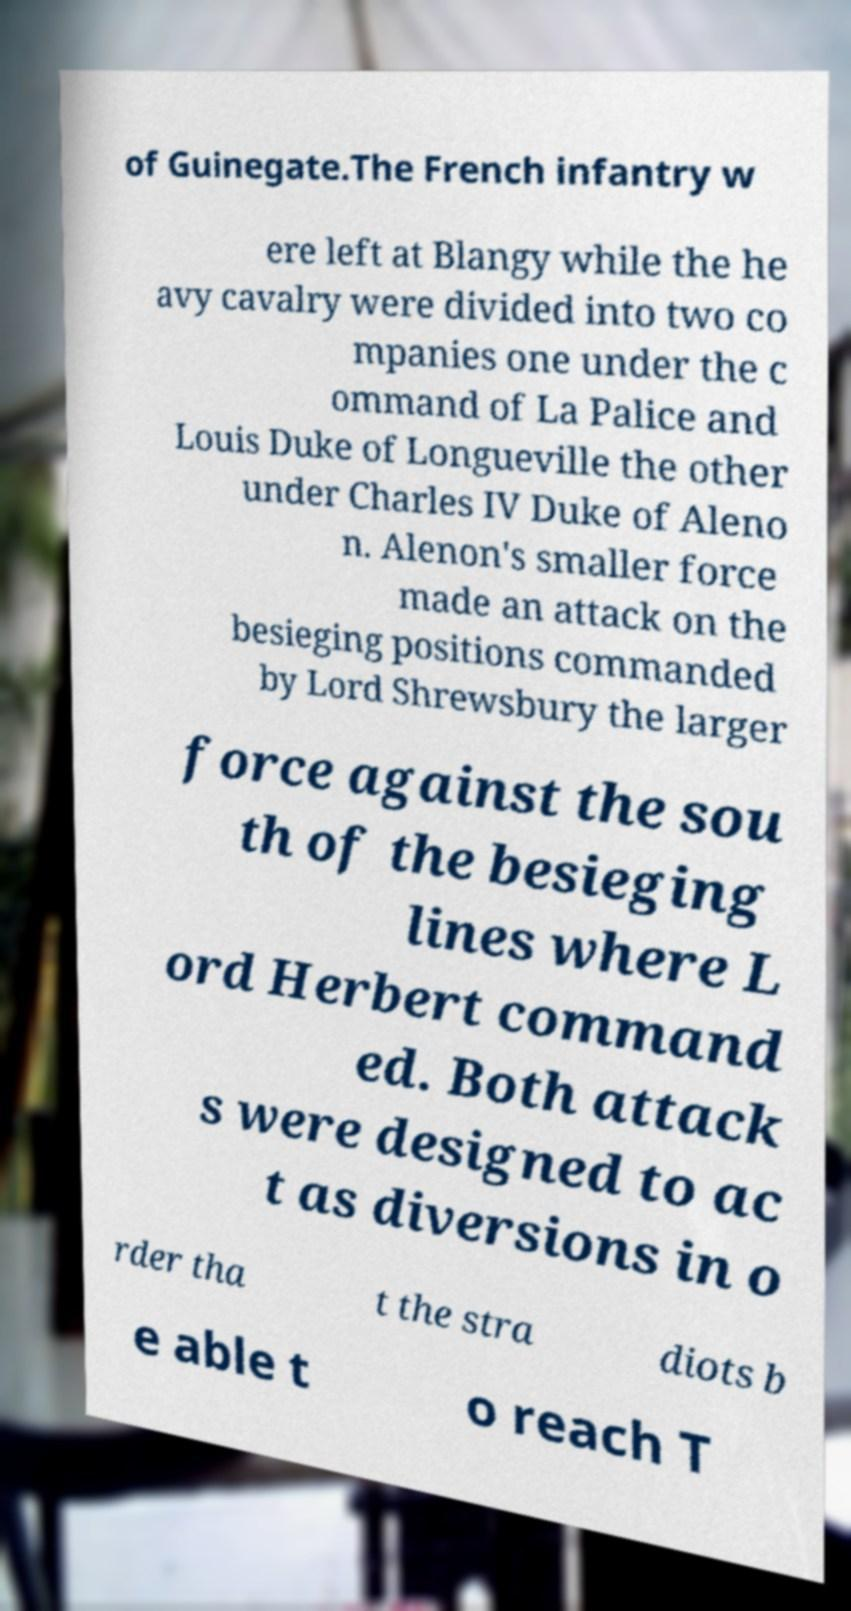Can you read and provide the text displayed in the image?This photo seems to have some interesting text. Can you extract and type it out for me? of Guinegate.The French infantry w ere left at Blangy while the he avy cavalry were divided into two co mpanies one under the c ommand of La Palice and Louis Duke of Longueville the other under Charles IV Duke of Aleno n. Alenon's smaller force made an attack on the besieging positions commanded by Lord Shrewsbury the larger force against the sou th of the besieging lines where L ord Herbert command ed. Both attack s were designed to ac t as diversions in o rder tha t the stra diots b e able t o reach T 